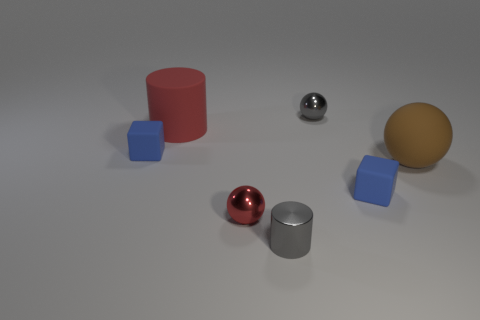There is another thing that is the same size as the brown object; what material is it?
Your answer should be very brief. Rubber. Are there any brown matte cylinders of the same size as the gray shiny sphere?
Offer a terse response. No. What is the color of the large rubber cylinder?
Give a very brief answer. Red. The sphere that is in front of the large brown matte sphere right of the large red thing is what color?
Provide a short and direct response. Red. There is a tiny gray object that is behind the blue cube that is on the right side of the sphere left of the small cylinder; what shape is it?
Offer a very short reply. Sphere. How many gray things have the same material as the tiny red thing?
Keep it short and to the point. 2. What number of blue objects are in front of the cube that is on the left side of the red matte object?
Offer a terse response. 1. How many red matte cylinders are there?
Your answer should be very brief. 1. Is the small gray cylinder made of the same material as the tiny gray object that is behind the big cylinder?
Give a very brief answer. Yes. There is a matte block that is on the left side of the small red metal thing; is it the same color as the small cylinder?
Make the answer very short. No. 